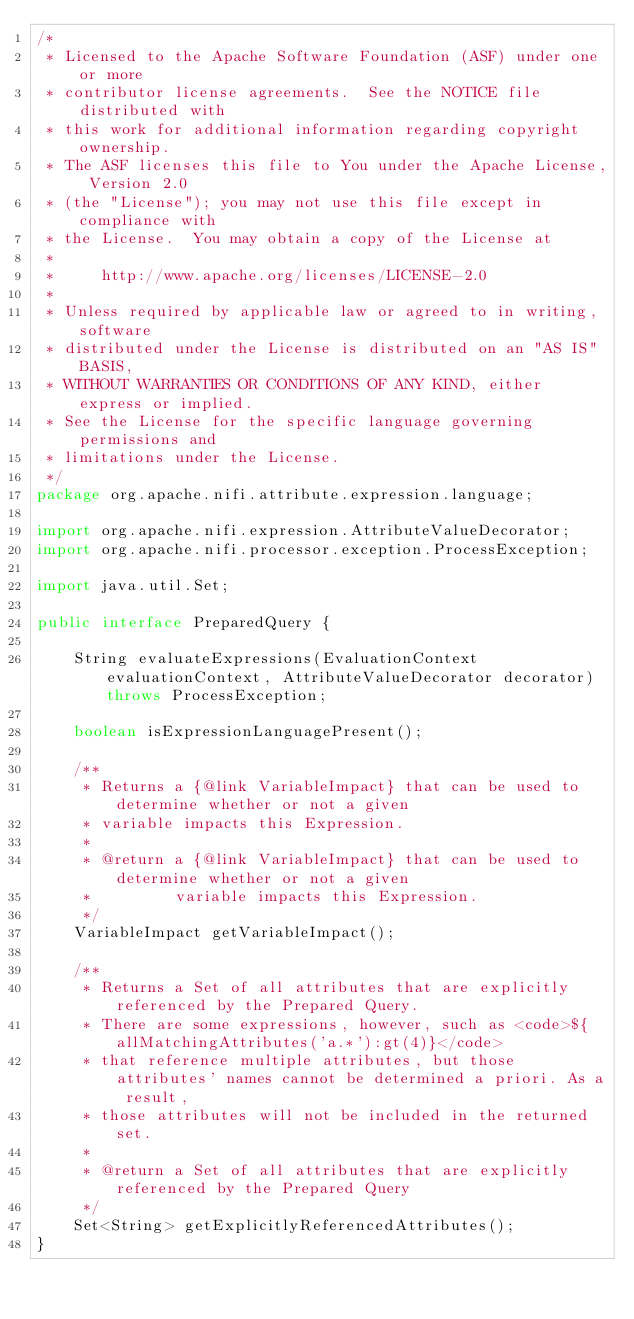Convert code to text. <code><loc_0><loc_0><loc_500><loc_500><_Java_>/*
 * Licensed to the Apache Software Foundation (ASF) under one or more
 * contributor license agreements.  See the NOTICE file distributed with
 * this work for additional information regarding copyright ownership.
 * The ASF licenses this file to You under the Apache License, Version 2.0
 * (the "License"); you may not use this file except in compliance with
 * the License.  You may obtain a copy of the License at
 *
 *     http://www.apache.org/licenses/LICENSE-2.0
 *
 * Unless required by applicable law or agreed to in writing, software
 * distributed under the License is distributed on an "AS IS" BASIS,
 * WITHOUT WARRANTIES OR CONDITIONS OF ANY KIND, either express or implied.
 * See the License for the specific language governing permissions and
 * limitations under the License.
 */
package org.apache.nifi.attribute.expression.language;

import org.apache.nifi.expression.AttributeValueDecorator;
import org.apache.nifi.processor.exception.ProcessException;

import java.util.Set;

public interface PreparedQuery {

    String evaluateExpressions(EvaluationContext evaluationContext, AttributeValueDecorator decorator) throws ProcessException;

    boolean isExpressionLanguagePresent();

    /**
     * Returns a {@link VariableImpact} that can be used to determine whether or not a given
     * variable impacts this Expression.
     *
     * @return a {@link VariableImpact} that can be used to determine whether or not a given
     *         variable impacts this Expression.
     */
    VariableImpact getVariableImpact();

    /**
     * Returns a Set of all attributes that are explicitly referenced by the Prepared Query.
     * There are some expressions, however, such as <code>${allMatchingAttributes('a.*'):gt(4)}</code>
     * that reference multiple attributes, but those attributes' names cannot be determined a priori. As a result,
     * those attributes will not be included in the returned set.
     *
     * @return a Set of all attributes that are explicitly referenced by the Prepared Query
     */
    Set<String> getExplicitlyReferencedAttributes();
}
</code> 